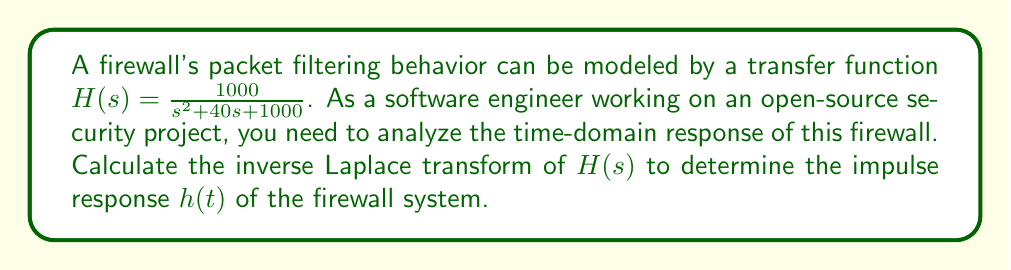What is the answer to this math problem? To find the inverse Laplace transform of $H(s)$, we'll follow these steps:

1) First, we recognize that the denominator of $H(s)$ is in the form of $s^2 + 2\zeta\omega_n s + \omega_n^2$, where $\zeta$ is the damping ratio and $\omega_n$ is the natural frequency.

2) Comparing our transfer function to this standard form:
   $s^2 + 40s + 1000 = s^2 + 2\zeta\omega_n s + \omega_n^2$

   We can deduce:
   $\omega_n^2 = 1000$, so $\omega_n = \sqrt{1000} \approx 31.62$
   $2\zeta\omega_n = 40$, so $\zeta = \frac{40}{2\sqrt{1000}} \approx 0.63$

3) For an underdamped system ($0 < \zeta < 1$), the inverse Laplace transform of $\frac{\omega_n^2}{s^2 + 2\zeta\omega_n s + \omega_n^2}$ is:

   $\frac{\omega_n}{\sqrt{1-\zeta^2}}e^{-\zeta\omega_n t}\sin(\omega_d t)$

   where $\omega_d = \omega_n\sqrt{1-\zeta^2}$ is the damped natural frequency.

4) Calculating $\omega_d$:
   $\omega_d = 31.62 \sqrt{1-0.63^2} \approx 24.25$

5) Substituting all values into the inverse Laplace transform formula:

   $h(t) = \frac{31.62}{\sqrt{1-0.63^2}}e^{-0.63 \cdot 31.62 t}\sin(24.25t)$

6) Simplifying:
   $h(t) \approx 52.19e^{-19.92t}\sin(24.25t)$

This function represents the impulse response of the firewall system in the time domain.
Answer: $h(t) = 52.19e^{-19.92t}\sin(24.25t)$ for $t \geq 0$ 